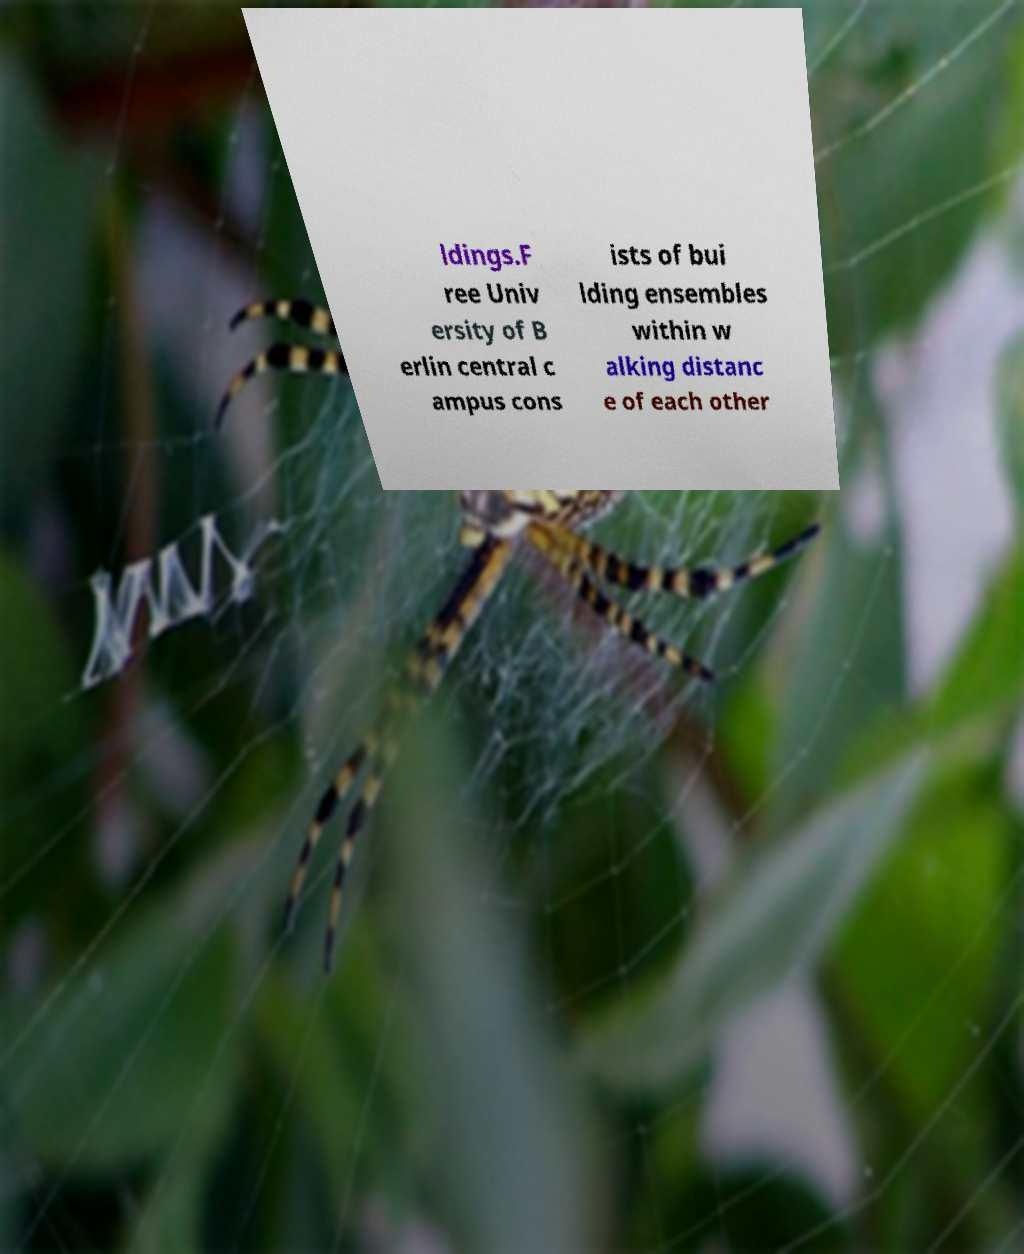Could you extract and type out the text from this image? ldings.F ree Univ ersity of B erlin central c ampus cons ists of bui lding ensembles within w alking distanc e of each other 